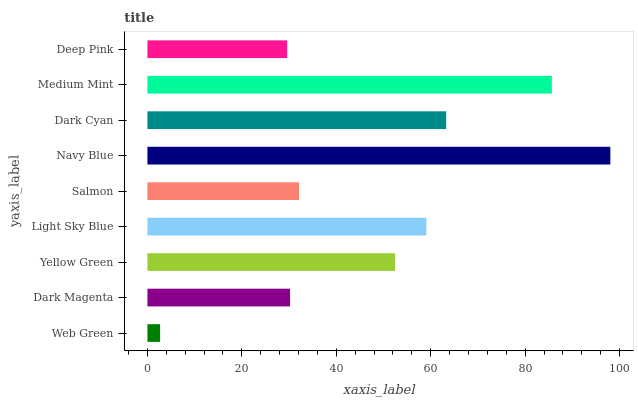Is Web Green the minimum?
Answer yes or no. Yes. Is Navy Blue the maximum?
Answer yes or no. Yes. Is Dark Magenta the minimum?
Answer yes or no. No. Is Dark Magenta the maximum?
Answer yes or no. No. Is Dark Magenta greater than Web Green?
Answer yes or no. Yes. Is Web Green less than Dark Magenta?
Answer yes or no. Yes. Is Web Green greater than Dark Magenta?
Answer yes or no. No. Is Dark Magenta less than Web Green?
Answer yes or no. No. Is Yellow Green the high median?
Answer yes or no. Yes. Is Yellow Green the low median?
Answer yes or no. Yes. Is Salmon the high median?
Answer yes or no. No. Is Dark Cyan the low median?
Answer yes or no. No. 